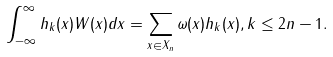<formula> <loc_0><loc_0><loc_500><loc_500>\int _ { - \infty } ^ { \infty } h _ { k } ( x ) W ( x ) d x = \sum _ { x \in X _ { n } } \omega ( x ) h _ { k } ( x ) , k \leq 2 n - 1 .</formula> 